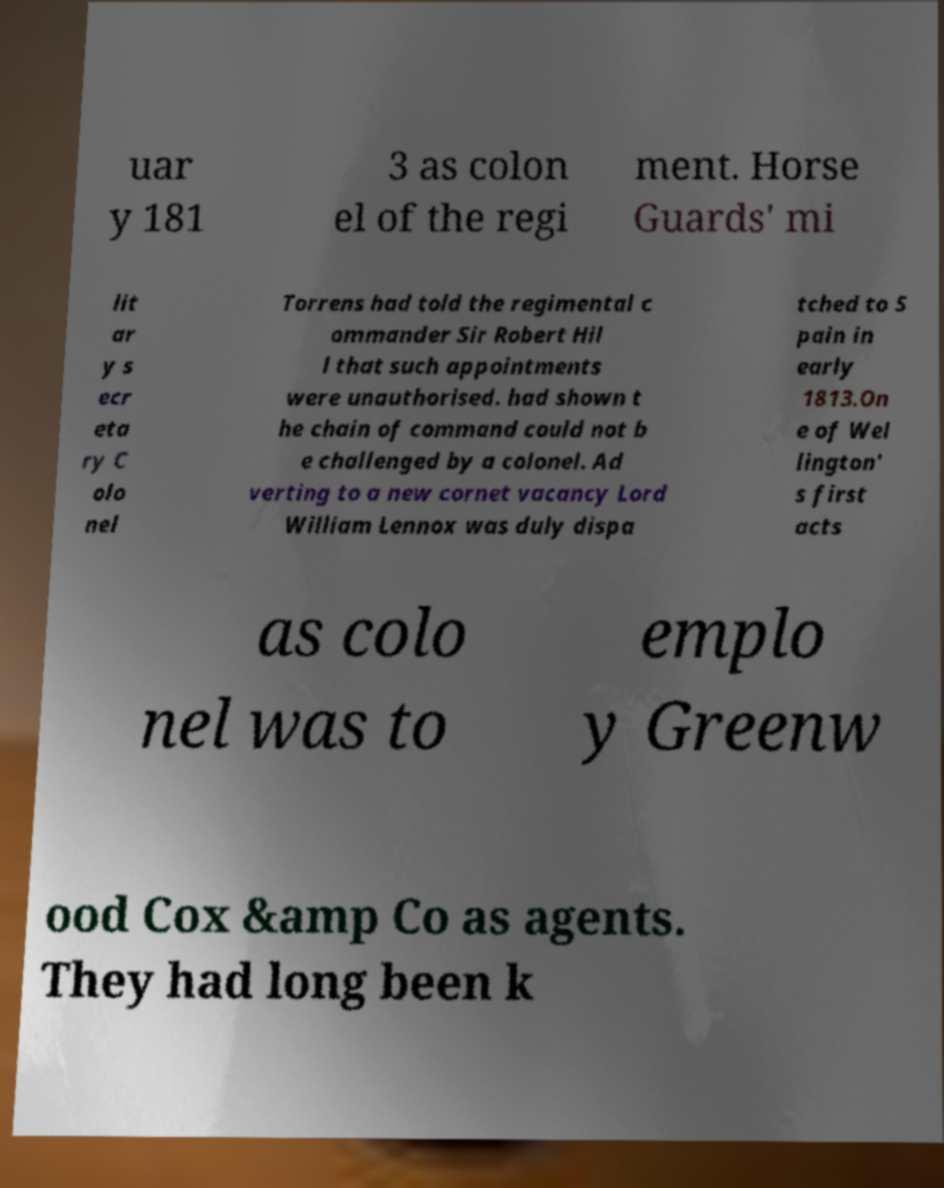Please read and relay the text visible in this image. What does it say? uar y 181 3 as colon el of the regi ment. Horse Guards' mi lit ar y s ecr eta ry C olo nel Torrens had told the regimental c ommander Sir Robert Hil l that such appointments were unauthorised. had shown t he chain of command could not b e challenged by a colonel. Ad verting to a new cornet vacancy Lord William Lennox was duly dispa tched to S pain in early 1813.On e of Wel lington' s first acts as colo nel was to emplo y Greenw ood Cox &amp Co as agents. They had long been k 